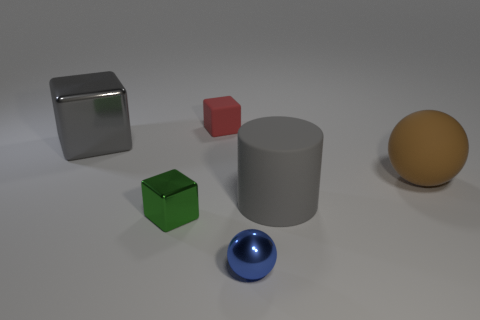There is a big thing that is right of the large cylinder; what is its shape?
Keep it short and to the point. Sphere. How many other objects are there of the same size as the green metallic object?
Your response must be concise. 2. There is a gray thing in front of the gray block; is it the same shape as the small object that is behind the large metallic cube?
Make the answer very short. No. What number of small green metal things are right of the gray rubber object?
Your answer should be compact. 0. There is a small cube behind the large cylinder; what is its color?
Provide a short and direct response. Red. What color is the other rubber thing that is the same shape as the blue object?
Your answer should be very brief. Brown. Is there anything else of the same color as the small matte object?
Give a very brief answer. No. Is the number of tiny purple blocks greater than the number of green objects?
Keep it short and to the point. No. Do the brown sphere and the tiny blue thing have the same material?
Offer a very short reply. No. What number of gray cubes are made of the same material as the big gray cylinder?
Provide a succinct answer. 0. 